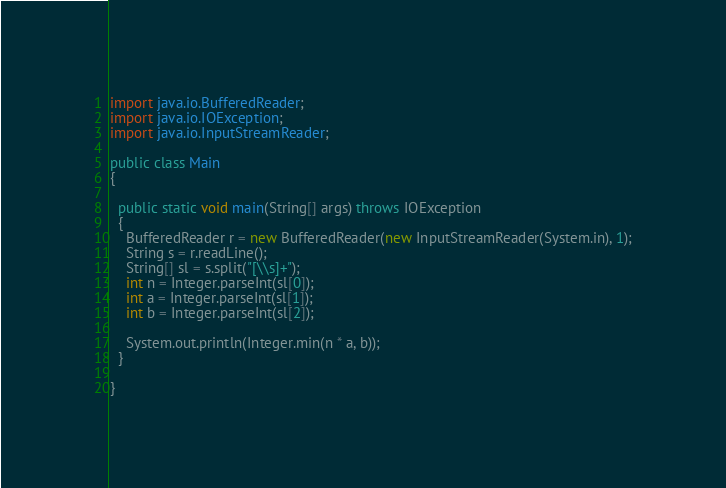<code> <loc_0><loc_0><loc_500><loc_500><_Java_>import java.io.BufferedReader;
import java.io.IOException;
import java.io.InputStreamReader;

public class Main
{

  public static void main(String[] args) throws IOException
  {
    BufferedReader r = new BufferedReader(new InputStreamReader(System.in), 1);
    String s = r.readLine();
    String[] sl = s.split("[\\s]+");
    int n = Integer.parseInt(sl[0]);
    int a = Integer.parseInt(sl[1]);
    int b = Integer.parseInt(sl[2]);
    
    System.out.println(Integer.min(n * a, b));
  }

}
</code> 